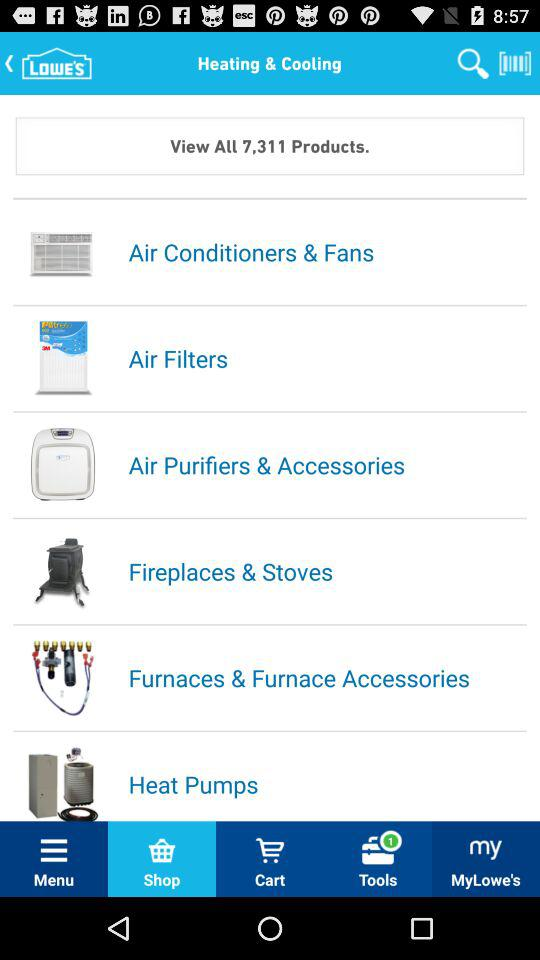What is the number of notifications?
When the provided information is insufficient, respond with <no answer>. <no answer> 